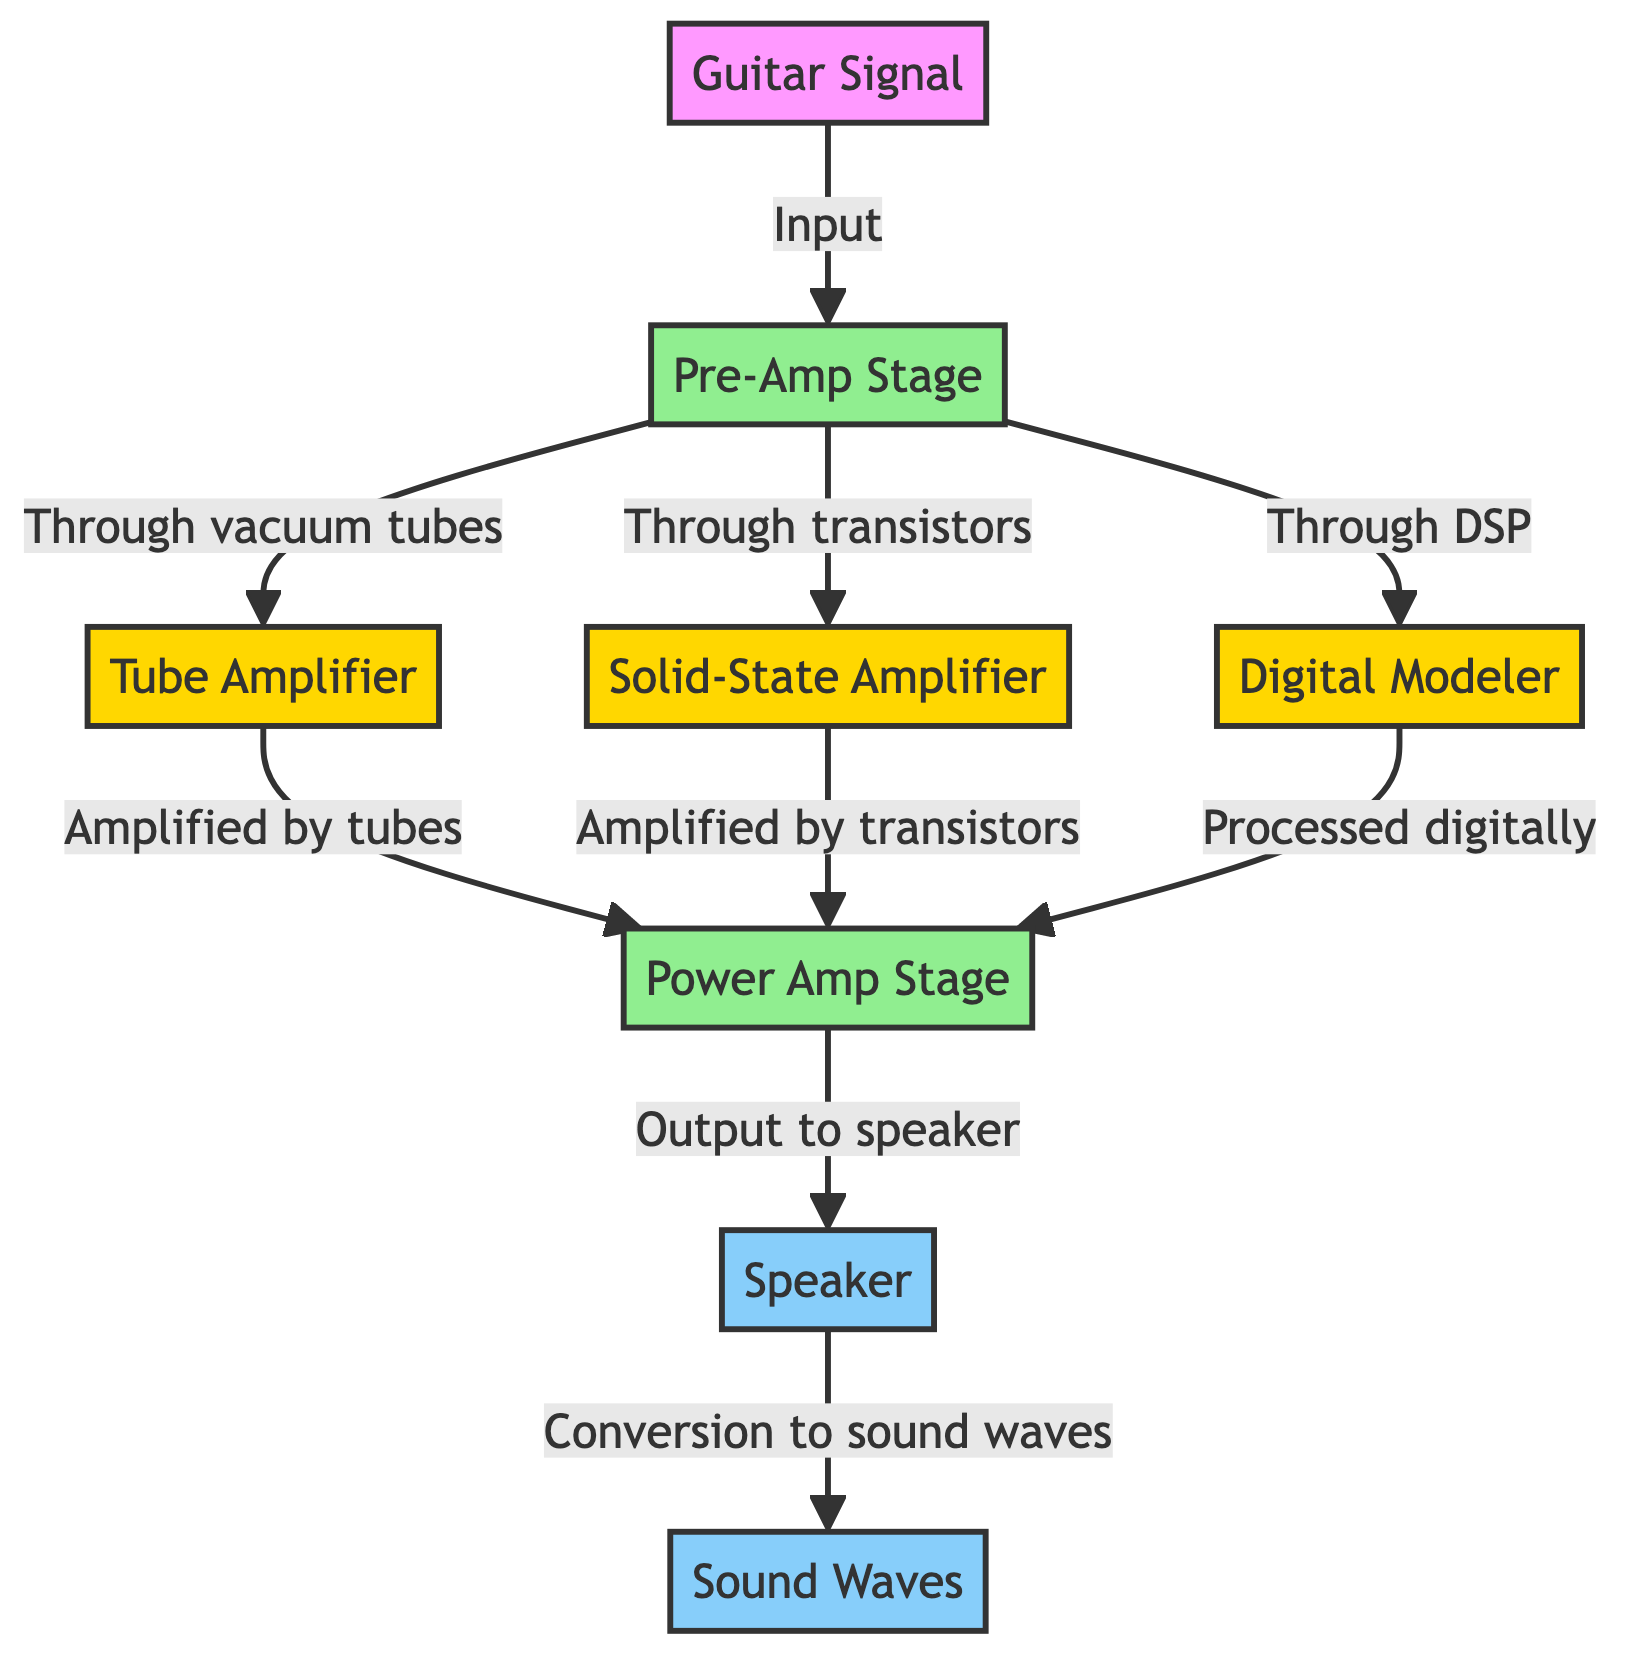What is the first stage after the guitar signal? The diagram shows the flow starting from the guitar signal leading directly to the pre-amp stage. Therefore, the first stage after the guitar signal is defined as the pre-amp stage.
Answer: pre-amp stage How many amplifier types are shown in the diagram? The diagram displays three different amplifier types: tube amplifier, solid-state amplifier, and digital modeler. By counting these, we find there are three types of amplifiers.
Answer: 3 What process does the tube amplifier use for amplification? In the diagram, the tube amplifier is indicated to amplify through vacuum tubes. This specific wording allows us to identify the method used in that particular amplification type.
Answer: vacuum tubes What connects the pre-amp stage to the power amp stage in all amplifier types? The diagram illustrates that all amplifier types (tube, solid-state, digital) flow from the pre-amp stage to the power amp stage, showing a direct output to the power amp stage from each amplifier type.
Answer: Output to power amp stage Which component converts the audio signal into sound waves? The last part of the flow in the diagram shows that the speaker converts the processed audio signal into sound waves. Thus, the speaker is identified as the component responsible for this conversion.
Answer: speaker Which amplifier processes audio digitally? According to the diagram, the digital modeler is the amplifier that processes the audio signal digitally, as indicated by the direct association in the flow from pre-amp stage to digital modeler.
Answer: digital modeler What type of signals do sound waves represent in this diagram? The diagram identifies sound waves as the output resulting from the speaker, which signifies that sound waves represent the auditory signals converted from electrical signals produced by amplifiers.
Answer: auditory signals What is the flow direction of the guitar signal in the diagram? The diagram illustrates that the flow direction of the guitar signal moves sequentially from the guitar signal to the pre-amp stage and then through the various amplifiers, leading to the final output to the speaker, indicating a left to right flow sequence.
Answer: left to right 